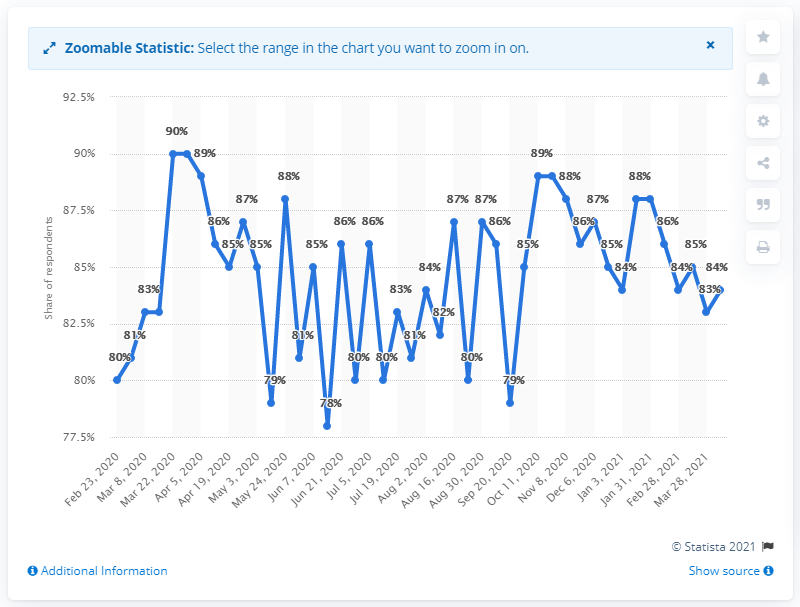List a handful of essential elements in this visual. According to a recent survey, 84% of Malaysians reported feeling concerned about contracting the COVID-19 virus. 